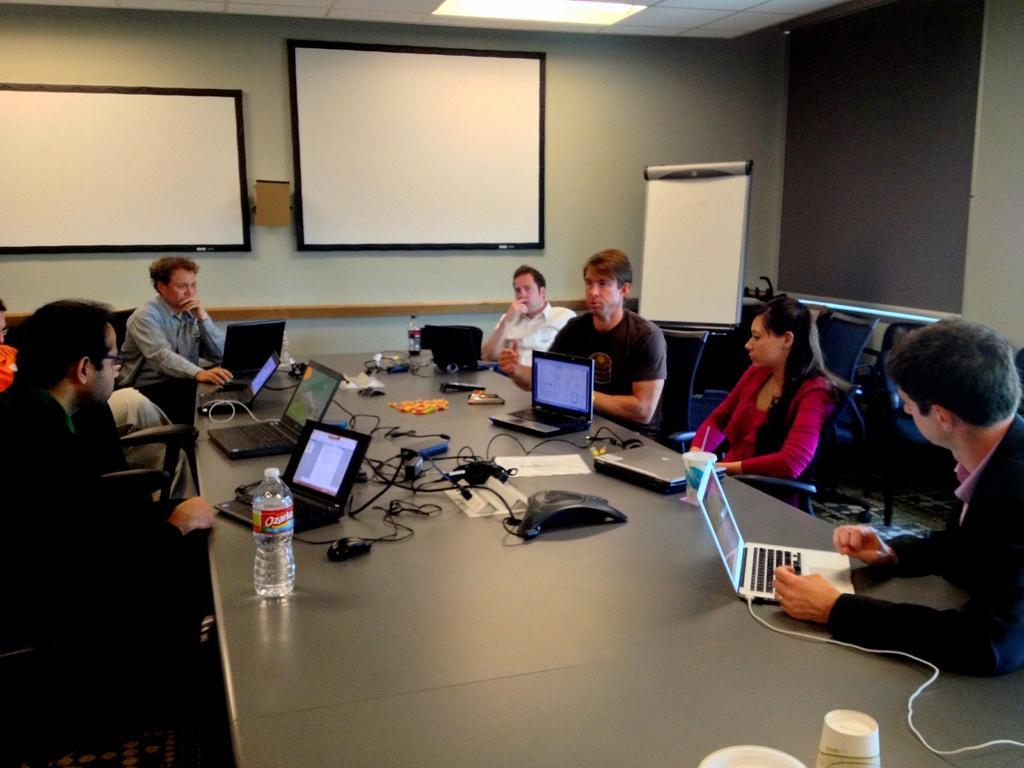Could you give a brief overview of what you see in this image? In this picture we can see there are groups of people sitting on chairs and in front of the people there is a table and on the table there are bottles, laptops, cables, cups and other things. Behind the people there is a wall with white boards and on the top there is a ceiling light. 